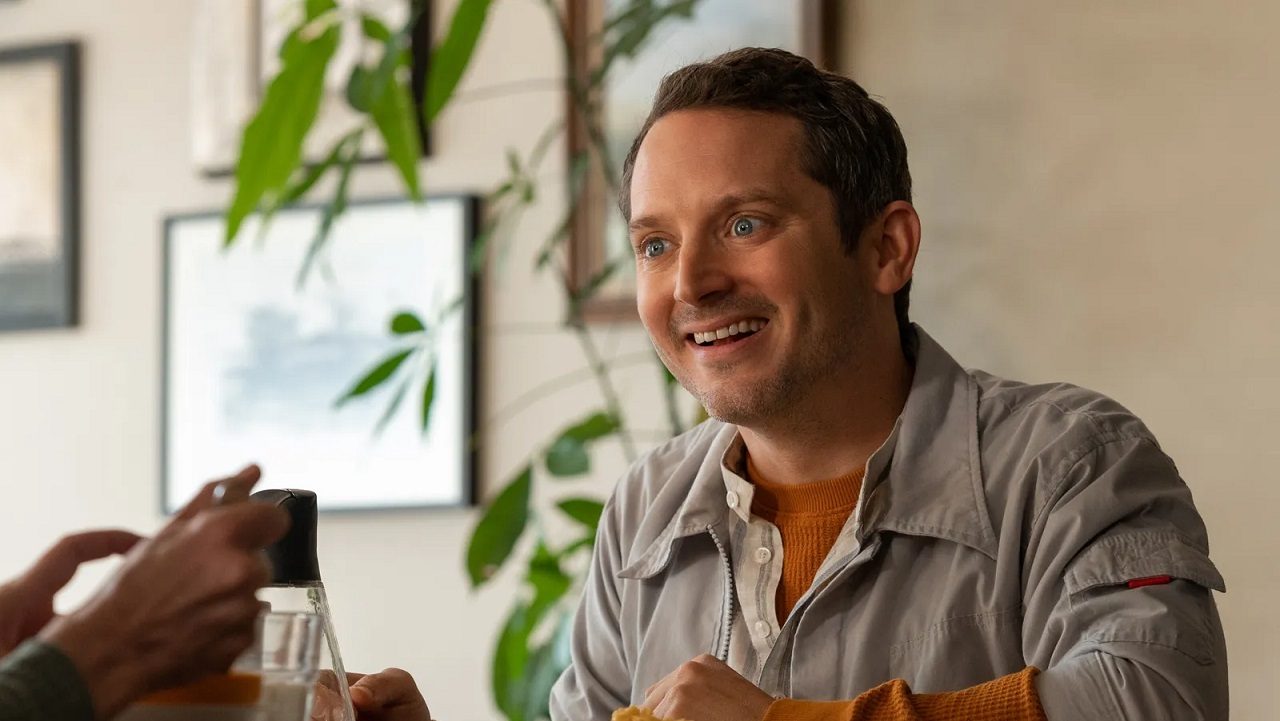Imagine what might have been said to make the person smile in such a way. Perhaps the person off-camera shared a funny story or a light-hearted joke that resonated well, given the warm and joyous expression on the man's face. Alternatively, it could be a heartfelt compliment or a piece of good news that brought about such a genuine smile and a look of admiration. 